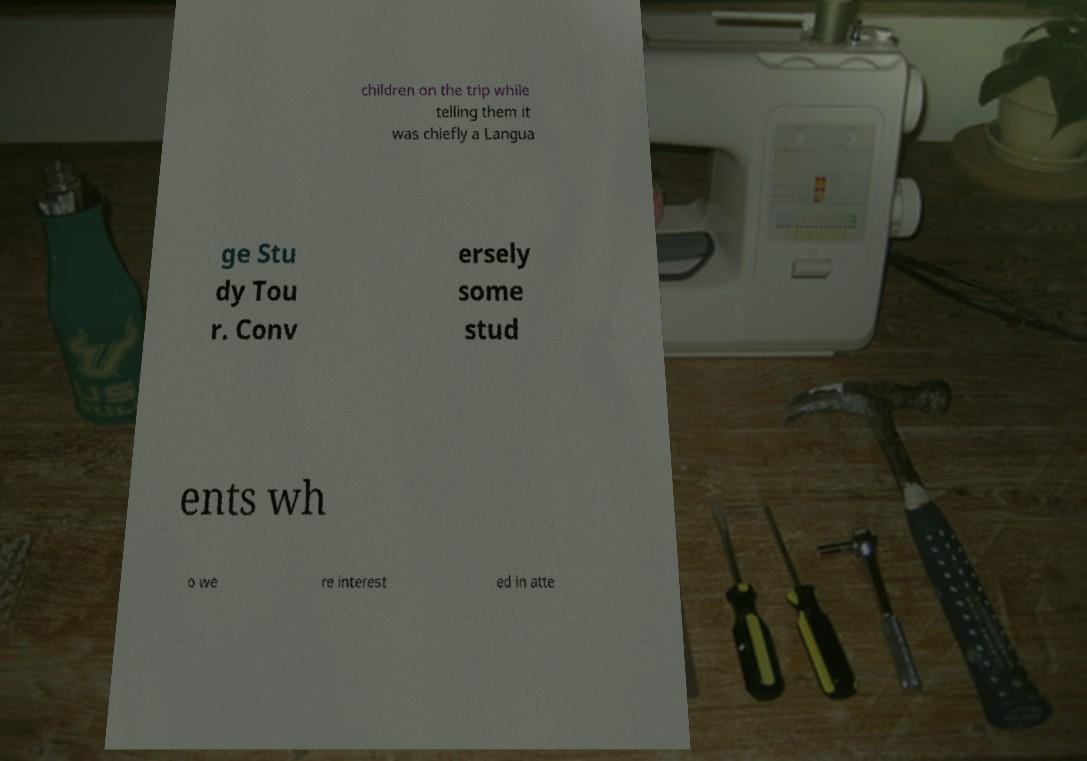Please read and relay the text visible in this image. What does it say? children on the trip while telling them it was chiefly a Langua ge Stu dy Tou r. Conv ersely some stud ents wh o we re interest ed in atte 